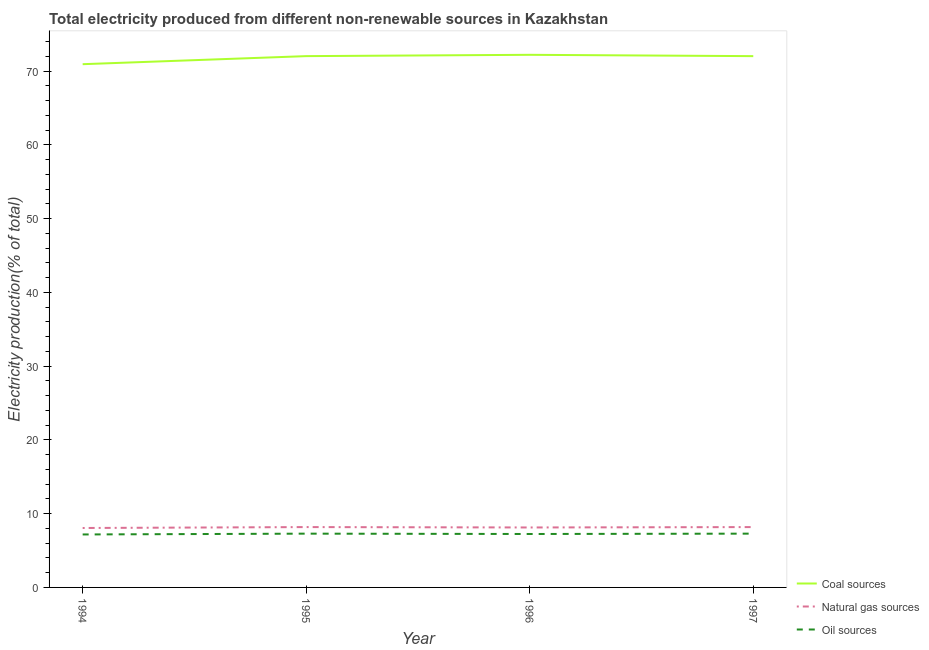How many different coloured lines are there?
Make the answer very short. 3. Does the line corresponding to percentage of electricity produced by coal intersect with the line corresponding to percentage of electricity produced by oil sources?
Your response must be concise. No. What is the percentage of electricity produced by coal in 1994?
Provide a short and direct response. 70.94. Across all years, what is the maximum percentage of electricity produced by oil sources?
Provide a succinct answer. 7.29. Across all years, what is the minimum percentage of electricity produced by coal?
Make the answer very short. 70.94. In which year was the percentage of electricity produced by coal minimum?
Provide a short and direct response. 1994. What is the total percentage of electricity produced by coal in the graph?
Your response must be concise. 287.21. What is the difference between the percentage of electricity produced by natural gas in 1994 and that in 1997?
Provide a succinct answer. -0.12. What is the difference between the percentage of electricity produced by oil sources in 1997 and the percentage of electricity produced by natural gas in 1995?
Provide a short and direct response. -0.89. What is the average percentage of electricity produced by natural gas per year?
Your answer should be very brief. 8.14. In the year 1994, what is the difference between the percentage of electricity produced by oil sources and percentage of electricity produced by coal?
Offer a very short reply. -63.76. What is the ratio of the percentage of electricity produced by coal in 1994 to that in 1996?
Make the answer very short. 0.98. What is the difference between the highest and the second highest percentage of electricity produced by coal?
Your answer should be compact. 0.18. What is the difference between the highest and the lowest percentage of electricity produced by oil sources?
Your response must be concise. 0.11. In how many years, is the percentage of electricity produced by coal greater than the average percentage of electricity produced by coal taken over all years?
Ensure brevity in your answer.  3. Is the percentage of electricity produced by coal strictly greater than the percentage of electricity produced by natural gas over the years?
Your answer should be compact. Yes. How many lines are there?
Give a very brief answer. 3. What is the difference between two consecutive major ticks on the Y-axis?
Offer a very short reply. 10. Are the values on the major ticks of Y-axis written in scientific E-notation?
Ensure brevity in your answer.  No. How many legend labels are there?
Provide a short and direct response. 3. What is the title of the graph?
Your response must be concise. Total electricity produced from different non-renewable sources in Kazakhstan. What is the Electricity production(% of total) of Coal sources in 1994?
Provide a succinct answer. 70.94. What is the Electricity production(% of total) of Natural gas sources in 1994?
Make the answer very short. 8.06. What is the Electricity production(% of total) in Oil sources in 1994?
Your answer should be very brief. 7.18. What is the Electricity production(% of total) of Coal sources in 1995?
Offer a very short reply. 72.03. What is the Electricity production(% of total) in Natural gas sources in 1995?
Your answer should be very brief. 8.18. What is the Electricity production(% of total) in Oil sources in 1995?
Your answer should be compact. 7.29. What is the Electricity production(% of total) of Coal sources in 1996?
Ensure brevity in your answer.  72.21. What is the Electricity production(% of total) of Natural gas sources in 1996?
Give a very brief answer. 8.13. What is the Electricity production(% of total) in Oil sources in 1996?
Offer a terse response. 7.24. What is the Electricity production(% of total) in Coal sources in 1997?
Provide a succinct answer. 72.03. What is the Electricity production(% of total) of Natural gas sources in 1997?
Your answer should be very brief. 8.18. What is the Electricity production(% of total) in Oil sources in 1997?
Provide a succinct answer. 7.29. Across all years, what is the maximum Electricity production(% of total) in Coal sources?
Your answer should be compact. 72.21. Across all years, what is the maximum Electricity production(% of total) of Natural gas sources?
Offer a very short reply. 8.18. Across all years, what is the maximum Electricity production(% of total) of Oil sources?
Your response must be concise. 7.29. Across all years, what is the minimum Electricity production(% of total) of Coal sources?
Your response must be concise. 70.94. Across all years, what is the minimum Electricity production(% of total) in Natural gas sources?
Provide a succinct answer. 8.06. Across all years, what is the minimum Electricity production(% of total) in Oil sources?
Provide a succinct answer. 7.18. What is the total Electricity production(% of total) of Coal sources in the graph?
Your response must be concise. 287.21. What is the total Electricity production(% of total) of Natural gas sources in the graph?
Your answer should be very brief. 32.55. What is the total Electricity production(% of total) in Oil sources in the graph?
Your response must be concise. 29.01. What is the difference between the Electricity production(% of total) in Coal sources in 1994 and that in 1995?
Offer a very short reply. -1.09. What is the difference between the Electricity production(% of total) of Natural gas sources in 1994 and that in 1995?
Provide a succinct answer. -0.12. What is the difference between the Electricity production(% of total) of Oil sources in 1994 and that in 1995?
Provide a succinct answer. -0.11. What is the difference between the Electricity production(% of total) in Coal sources in 1994 and that in 1996?
Provide a succinct answer. -1.27. What is the difference between the Electricity production(% of total) in Natural gas sources in 1994 and that in 1996?
Offer a very short reply. -0.07. What is the difference between the Electricity production(% of total) of Oil sources in 1994 and that in 1996?
Your answer should be very brief. -0.06. What is the difference between the Electricity production(% of total) in Coal sources in 1994 and that in 1997?
Provide a short and direct response. -1.09. What is the difference between the Electricity production(% of total) of Natural gas sources in 1994 and that in 1997?
Ensure brevity in your answer.  -0.12. What is the difference between the Electricity production(% of total) in Oil sources in 1994 and that in 1997?
Make the answer very short. -0.11. What is the difference between the Electricity production(% of total) in Coal sources in 1995 and that in 1996?
Your answer should be very brief. -0.18. What is the difference between the Electricity production(% of total) in Natural gas sources in 1995 and that in 1996?
Give a very brief answer. 0.05. What is the difference between the Electricity production(% of total) in Oil sources in 1995 and that in 1996?
Provide a short and direct response. 0.05. What is the difference between the Electricity production(% of total) of Coal sources in 1995 and that in 1997?
Your answer should be compact. 0. What is the difference between the Electricity production(% of total) in Natural gas sources in 1995 and that in 1997?
Keep it short and to the point. 0. What is the difference between the Electricity production(% of total) of Oil sources in 1995 and that in 1997?
Give a very brief answer. -0. What is the difference between the Electricity production(% of total) of Coal sources in 1996 and that in 1997?
Your response must be concise. 0.18. What is the difference between the Electricity production(% of total) of Natural gas sources in 1996 and that in 1997?
Offer a very short reply. -0.05. What is the difference between the Electricity production(% of total) of Oil sources in 1996 and that in 1997?
Offer a very short reply. -0.05. What is the difference between the Electricity production(% of total) in Coal sources in 1994 and the Electricity production(% of total) in Natural gas sources in 1995?
Ensure brevity in your answer.  62.76. What is the difference between the Electricity production(% of total) of Coal sources in 1994 and the Electricity production(% of total) of Oil sources in 1995?
Ensure brevity in your answer.  63.65. What is the difference between the Electricity production(% of total) in Natural gas sources in 1994 and the Electricity production(% of total) in Oil sources in 1995?
Keep it short and to the point. 0.77. What is the difference between the Electricity production(% of total) in Coal sources in 1994 and the Electricity production(% of total) in Natural gas sources in 1996?
Ensure brevity in your answer.  62.81. What is the difference between the Electricity production(% of total) in Coal sources in 1994 and the Electricity production(% of total) in Oil sources in 1996?
Your answer should be compact. 63.69. What is the difference between the Electricity production(% of total) in Natural gas sources in 1994 and the Electricity production(% of total) in Oil sources in 1996?
Your answer should be very brief. 0.81. What is the difference between the Electricity production(% of total) of Coal sources in 1994 and the Electricity production(% of total) of Natural gas sources in 1997?
Your answer should be compact. 62.76. What is the difference between the Electricity production(% of total) in Coal sources in 1994 and the Electricity production(% of total) in Oil sources in 1997?
Give a very brief answer. 63.64. What is the difference between the Electricity production(% of total) in Natural gas sources in 1994 and the Electricity production(% of total) in Oil sources in 1997?
Keep it short and to the point. 0.77. What is the difference between the Electricity production(% of total) in Coal sources in 1995 and the Electricity production(% of total) in Natural gas sources in 1996?
Offer a very short reply. 63.9. What is the difference between the Electricity production(% of total) of Coal sources in 1995 and the Electricity production(% of total) of Oil sources in 1996?
Keep it short and to the point. 64.79. What is the difference between the Electricity production(% of total) of Natural gas sources in 1995 and the Electricity production(% of total) of Oil sources in 1996?
Your answer should be compact. 0.94. What is the difference between the Electricity production(% of total) in Coal sources in 1995 and the Electricity production(% of total) in Natural gas sources in 1997?
Ensure brevity in your answer.  63.85. What is the difference between the Electricity production(% of total) in Coal sources in 1995 and the Electricity production(% of total) in Oil sources in 1997?
Your answer should be compact. 64.74. What is the difference between the Electricity production(% of total) of Natural gas sources in 1995 and the Electricity production(% of total) of Oil sources in 1997?
Ensure brevity in your answer.  0.89. What is the difference between the Electricity production(% of total) in Coal sources in 1996 and the Electricity production(% of total) in Natural gas sources in 1997?
Make the answer very short. 64.03. What is the difference between the Electricity production(% of total) in Coal sources in 1996 and the Electricity production(% of total) in Oil sources in 1997?
Your response must be concise. 64.92. What is the difference between the Electricity production(% of total) of Natural gas sources in 1996 and the Electricity production(% of total) of Oil sources in 1997?
Ensure brevity in your answer.  0.84. What is the average Electricity production(% of total) in Coal sources per year?
Offer a terse response. 71.8. What is the average Electricity production(% of total) in Natural gas sources per year?
Make the answer very short. 8.14. What is the average Electricity production(% of total) of Oil sources per year?
Give a very brief answer. 7.25. In the year 1994, what is the difference between the Electricity production(% of total) of Coal sources and Electricity production(% of total) of Natural gas sources?
Offer a terse response. 62.88. In the year 1994, what is the difference between the Electricity production(% of total) in Coal sources and Electricity production(% of total) in Oil sources?
Provide a succinct answer. 63.76. In the year 1994, what is the difference between the Electricity production(% of total) in Natural gas sources and Electricity production(% of total) in Oil sources?
Your response must be concise. 0.88. In the year 1995, what is the difference between the Electricity production(% of total) of Coal sources and Electricity production(% of total) of Natural gas sources?
Offer a very short reply. 63.85. In the year 1995, what is the difference between the Electricity production(% of total) of Coal sources and Electricity production(% of total) of Oil sources?
Your response must be concise. 64.74. In the year 1995, what is the difference between the Electricity production(% of total) of Natural gas sources and Electricity production(% of total) of Oil sources?
Offer a very short reply. 0.89. In the year 1996, what is the difference between the Electricity production(% of total) in Coal sources and Electricity production(% of total) in Natural gas sources?
Your response must be concise. 64.08. In the year 1996, what is the difference between the Electricity production(% of total) in Coal sources and Electricity production(% of total) in Oil sources?
Ensure brevity in your answer.  64.96. In the year 1996, what is the difference between the Electricity production(% of total) in Natural gas sources and Electricity production(% of total) in Oil sources?
Offer a very short reply. 0.88. In the year 1997, what is the difference between the Electricity production(% of total) of Coal sources and Electricity production(% of total) of Natural gas sources?
Provide a short and direct response. 63.85. In the year 1997, what is the difference between the Electricity production(% of total) of Coal sources and Electricity production(% of total) of Oil sources?
Ensure brevity in your answer.  64.74. In the year 1997, what is the difference between the Electricity production(% of total) of Natural gas sources and Electricity production(% of total) of Oil sources?
Your answer should be compact. 0.89. What is the ratio of the Electricity production(% of total) in Coal sources in 1994 to that in 1995?
Your response must be concise. 0.98. What is the ratio of the Electricity production(% of total) in Natural gas sources in 1994 to that in 1995?
Your answer should be very brief. 0.98. What is the ratio of the Electricity production(% of total) in Oil sources in 1994 to that in 1995?
Ensure brevity in your answer.  0.98. What is the ratio of the Electricity production(% of total) in Coal sources in 1994 to that in 1996?
Make the answer very short. 0.98. What is the ratio of the Electricity production(% of total) in Natural gas sources in 1994 to that in 1997?
Make the answer very short. 0.98. What is the ratio of the Electricity production(% of total) of Oil sources in 1994 to that in 1997?
Provide a short and direct response. 0.98. What is the ratio of the Electricity production(% of total) of Coal sources in 1995 to that in 1996?
Offer a very short reply. 1. What is the ratio of the Electricity production(% of total) in Oil sources in 1995 to that in 1996?
Provide a succinct answer. 1.01. What is the ratio of the Electricity production(% of total) of Coal sources in 1995 to that in 1997?
Provide a short and direct response. 1. What is the ratio of the Electricity production(% of total) in Oil sources in 1996 to that in 1997?
Give a very brief answer. 0.99. What is the difference between the highest and the second highest Electricity production(% of total) in Coal sources?
Your answer should be very brief. 0.18. What is the difference between the highest and the second highest Electricity production(% of total) of Natural gas sources?
Give a very brief answer. 0. What is the difference between the highest and the second highest Electricity production(% of total) in Oil sources?
Provide a short and direct response. 0. What is the difference between the highest and the lowest Electricity production(% of total) in Coal sources?
Your answer should be very brief. 1.27. What is the difference between the highest and the lowest Electricity production(% of total) of Natural gas sources?
Your response must be concise. 0.12. What is the difference between the highest and the lowest Electricity production(% of total) in Oil sources?
Your answer should be compact. 0.11. 